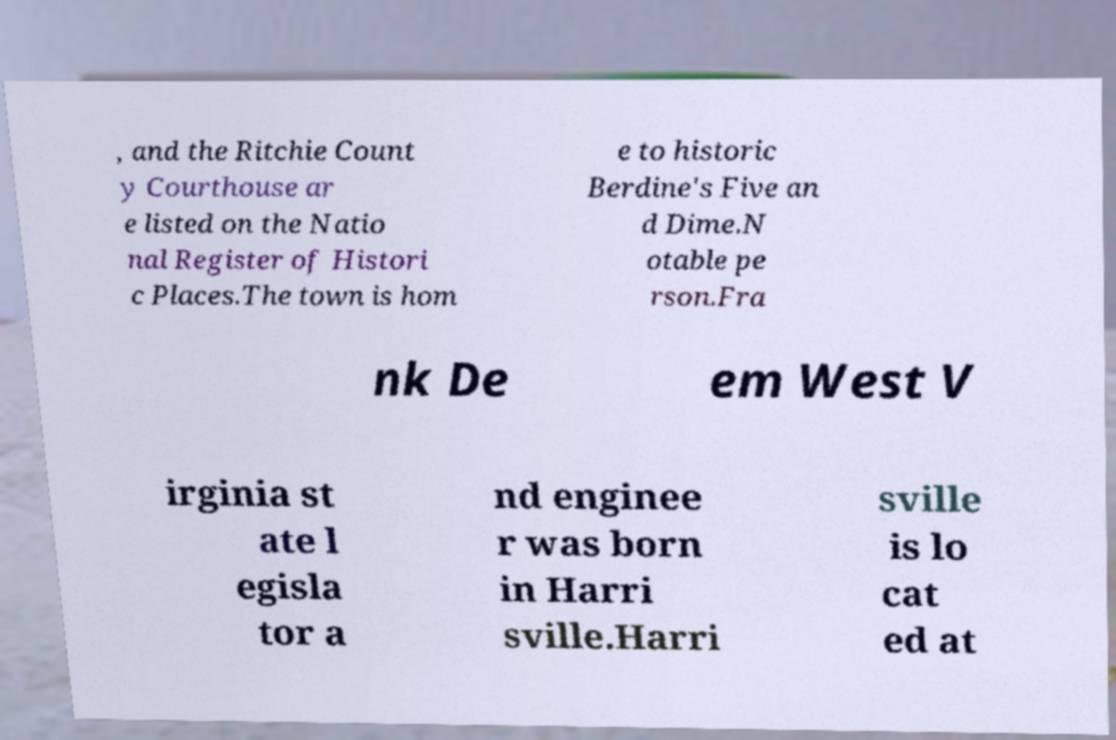Can you read and provide the text displayed in the image?This photo seems to have some interesting text. Can you extract and type it out for me? , and the Ritchie Count y Courthouse ar e listed on the Natio nal Register of Histori c Places.The town is hom e to historic Berdine's Five an d Dime.N otable pe rson.Fra nk De em West V irginia st ate l egisla tor a nd enginee r was born in Harri sville.Harri sville is lo cat ed at 